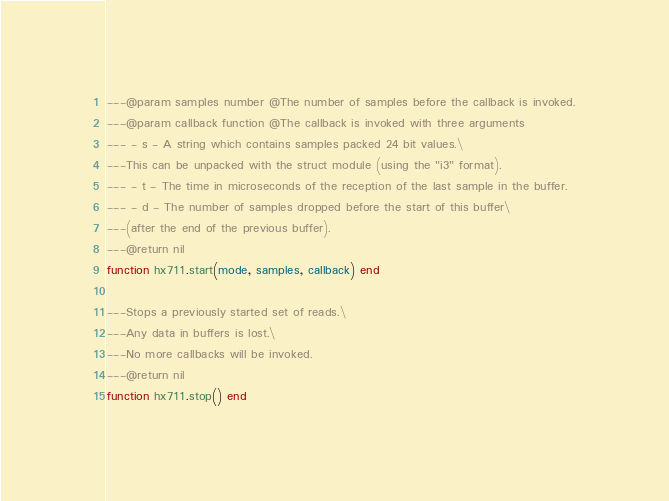Convert code to text. <code><loc_0><loc_0><loc_500><loc_500><_Lua_>---@param samples number @The number of samples before the callback is invoked.
---@param callback function @The callback is invoked with three arguments
--- - s - A string which contains samples packed 24 bit values.\
---This can be unpacked with the struct module (using the "i3" format).
--- - t - The time in microseconds of the reception of the last sample in the buffer.
--- - d - The number of samples dropped before the start of this buffer\
---(after the end of the previous buffer).
---@return nil
function hx711.start(mode, samples, callback) end

---Stops a previously started set of reads.\
---Any data in buffers is lost.\
---No more callbacks will be invoked.
---@return nil
function hx711.stop() end
</code> 